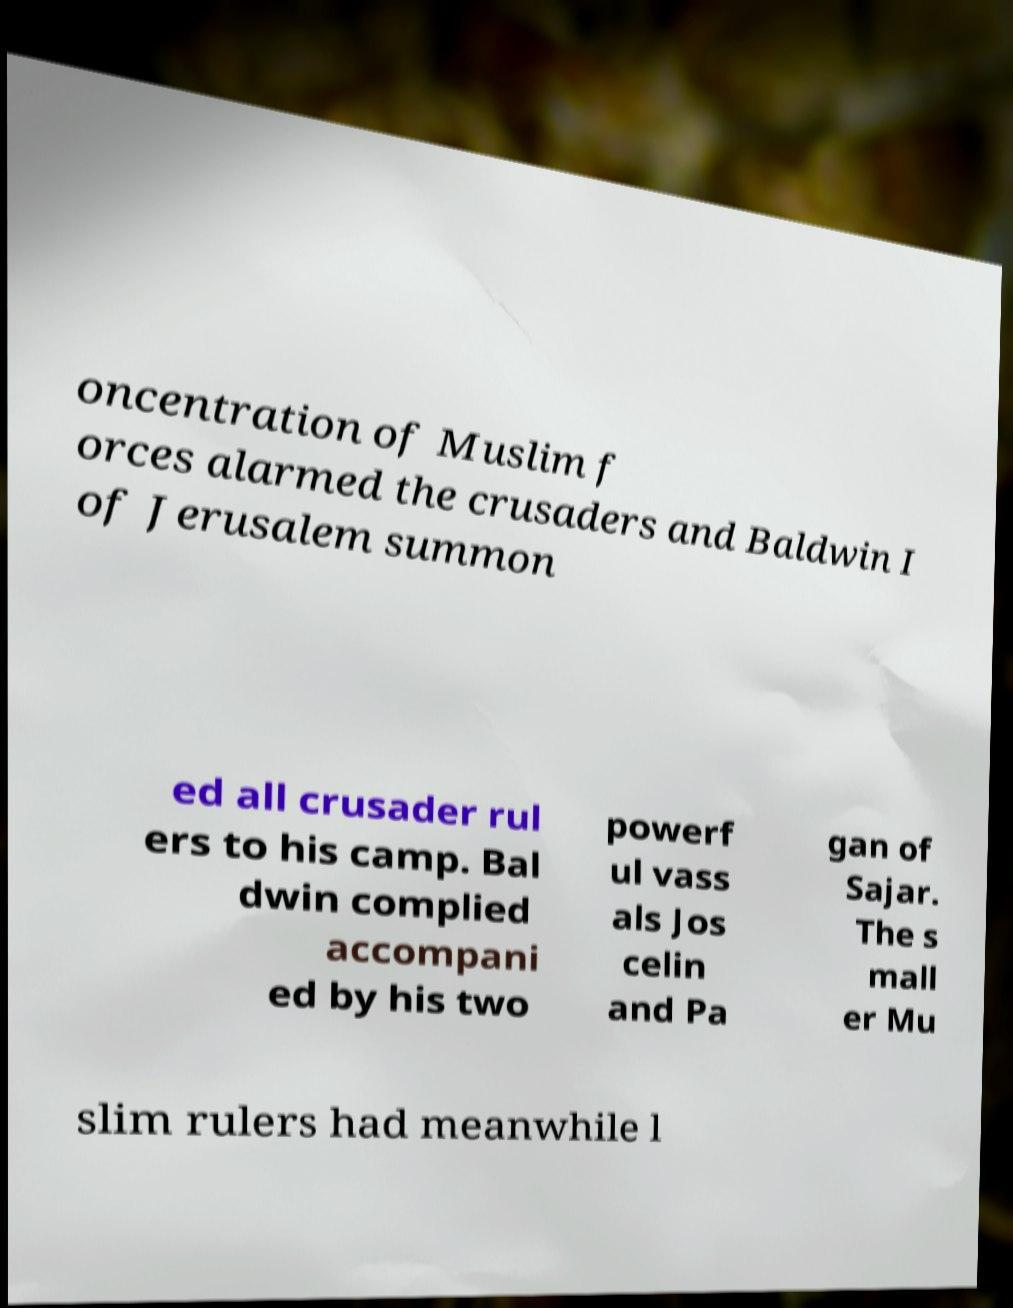What messages or text are displayed in this image? I need them in a readable, typed format. oncentration of Muslim f orces alarmed the crusaders and Baldwin I of Jerusalem summon ed all crusader rul ers to his camp. Bal dwin complied accompani ed by his two powerf ul vass als Jos celin and Pa gan of Sajar. The s mall er Mu slim rulers had meanwhile l 